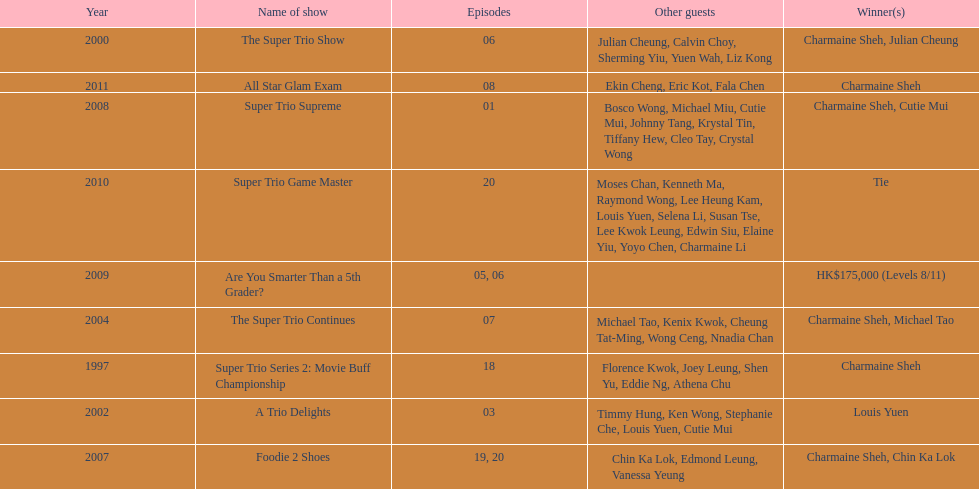How many times has charmaine sheh won on a variety show? 6. 